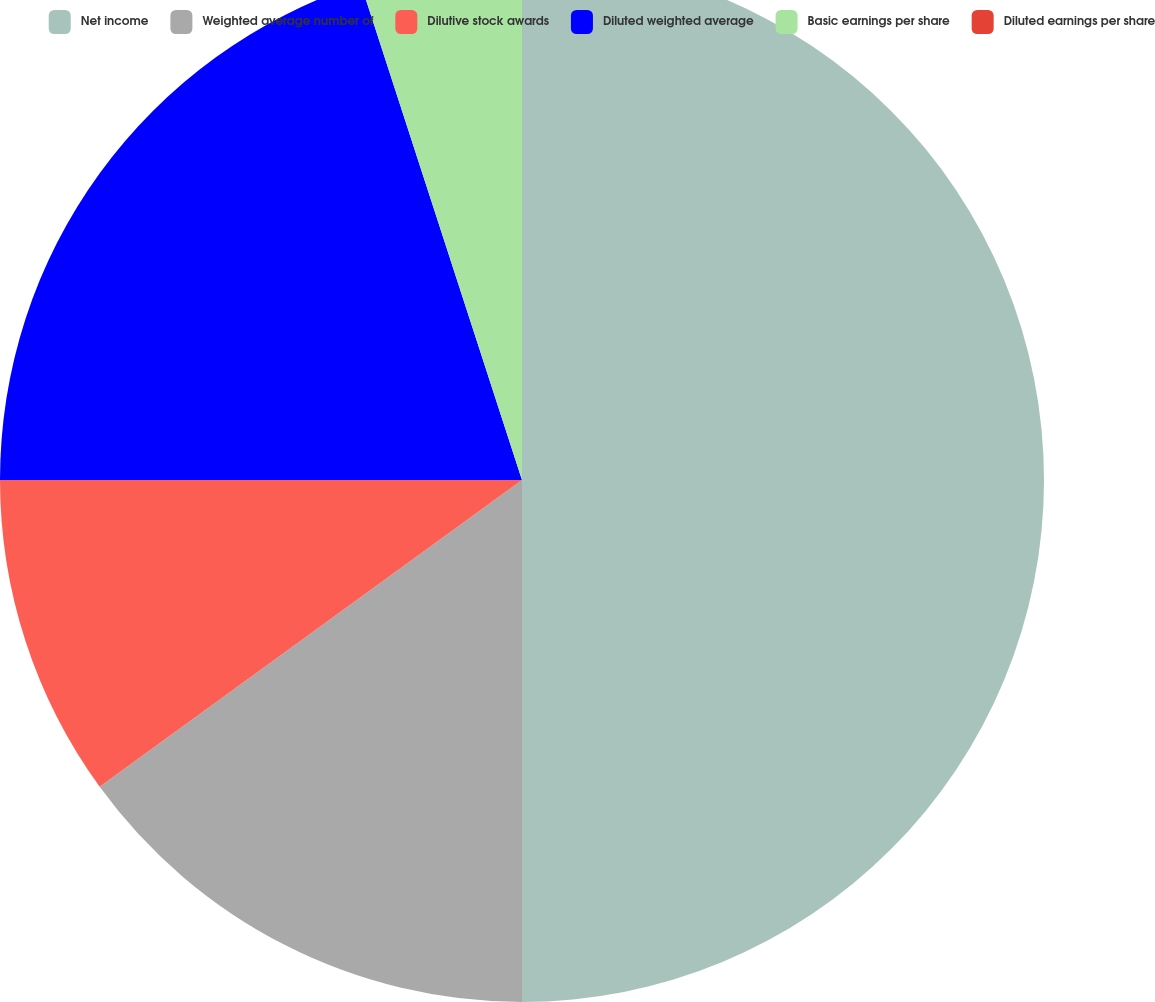Convert chart. <chart><loc_0><loc_0><loc_500><loc_500><pie_chart><fcel>Net income<fcel>Weighted average number of<fcel>Dilutive stock awards<fcel>Diluted weighted average<fcel>Basic earnings per share<fcel>Diluted earnings per share<nl><fcel>50.0%<fcel>15.0%<fcel>10.0%<fcel>20.0%<fcel>5.0%<fcel>0.0%<nl></chart> 